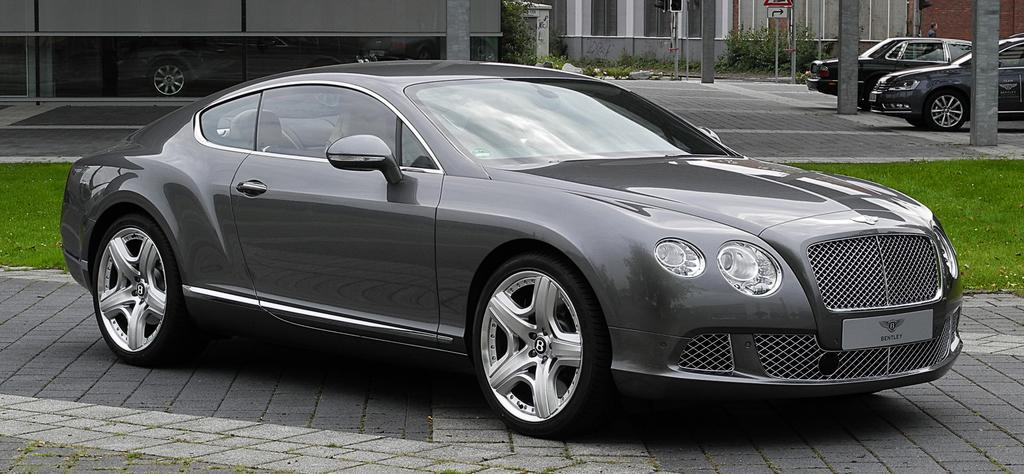How many cars are in the image? There are three cars in the image. What type of vegetation is visible in the image? There is grass visible in the image. What can be seen in the background of the image? There is a building, pillars, a board, poles, and plants in the background of the image. What type of stocking is being used by the beginner in the image? There is no stocking or beginner present in the image. What is the plot of the story being told in the image? The image does not depict a story or plot; it is a scene with cars, grass, and background elements. 